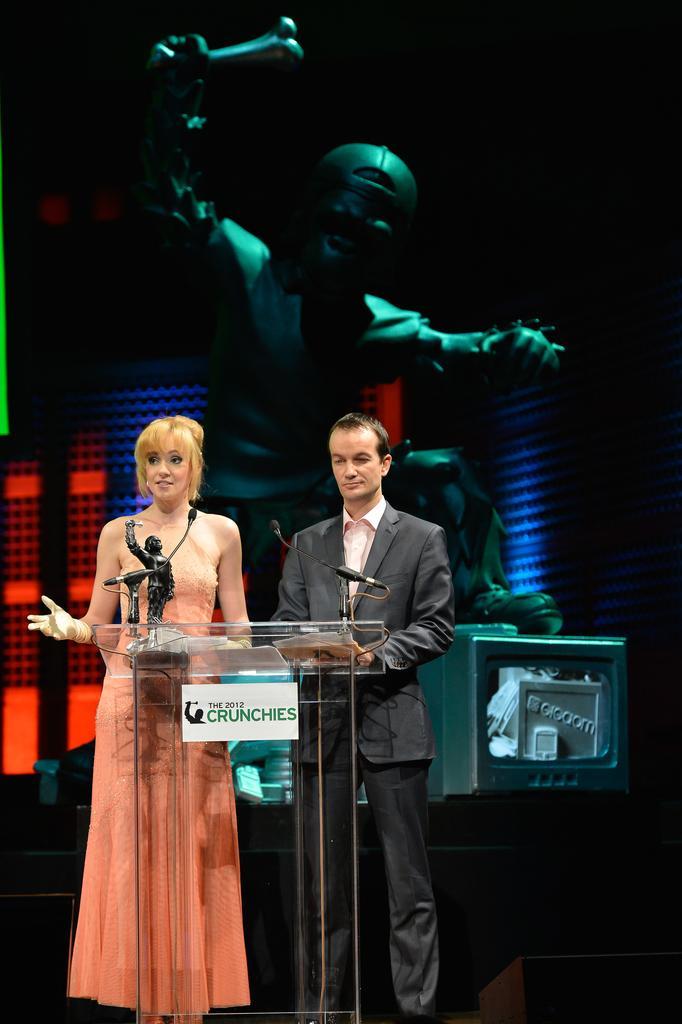How would you summarize this image in a sentence or two? In this image I can see the glass podium and behind it I can see a woman wearing orange colored dress and a person wearing black colored blazer and black colored pant are standing. On the podium I can see few papers, few microphones and a black colored object. In the background I can see a huge statue, a green colored box and the dark background. 